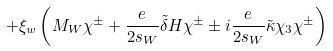<formula> <loc_0><loc_0><loc_500><loc_500>+ \xi _ { w } \left ( M _ { W } \chi ^ { \pm } + \frac { e } { 2 s _ { W } } \tilde { \delta } H \chi ^ { \pm } \pm i \frac { e } { 2 s _ { W } } \tilde { \kappa } \chi _ { 3 } \chi ^ { \pm } \right )</formula> 